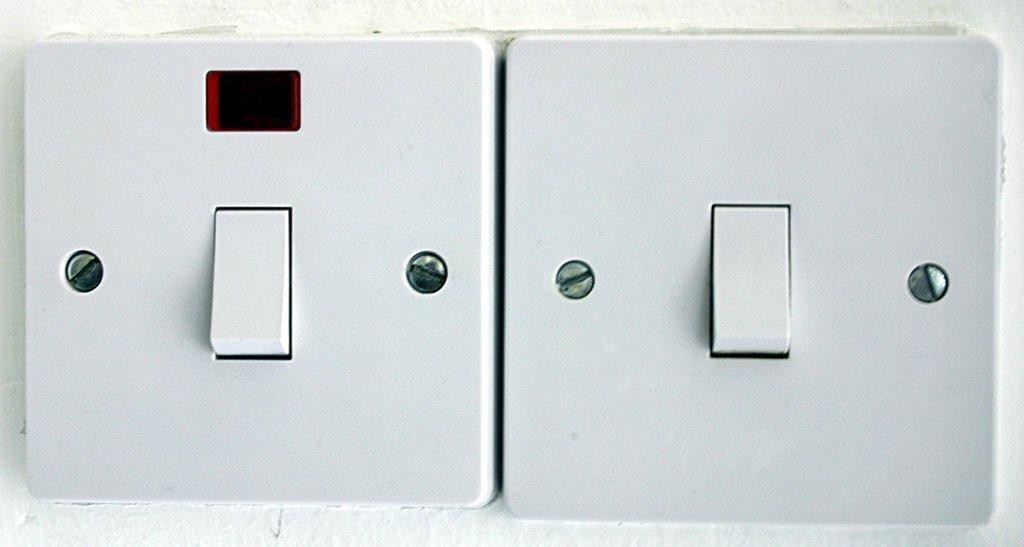Can you describe this image briefly? These are the two switches which are in white color. 